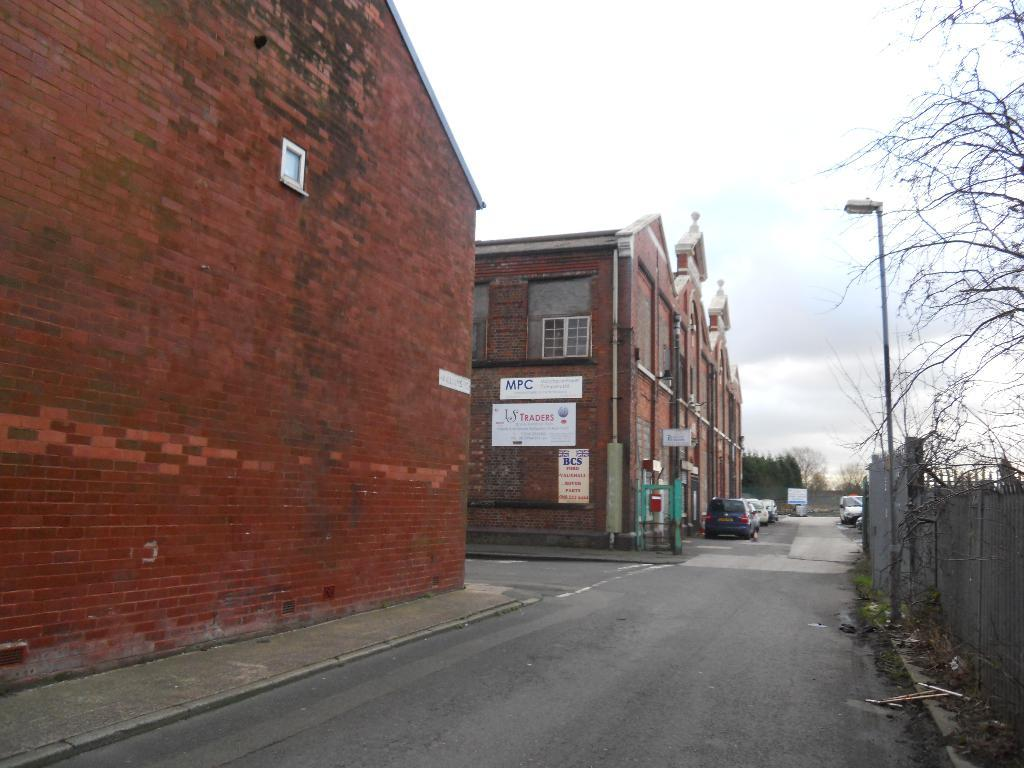What is the main feature of the image? There is a road in the image. What else can be seen along the road? There are vehicles in a parking space and trees visible in the image. What structures are present in the image? There is a light pole and buildings in the image. What is visible in the sky? Clouds are present in the sky. What type of pencil is the boy holding in the image? There is no boy or pencil present in the image. What is the title of the image? The image does not have a title, as it is a photograph or illustration and not a piece of literature or art with a specific title. 